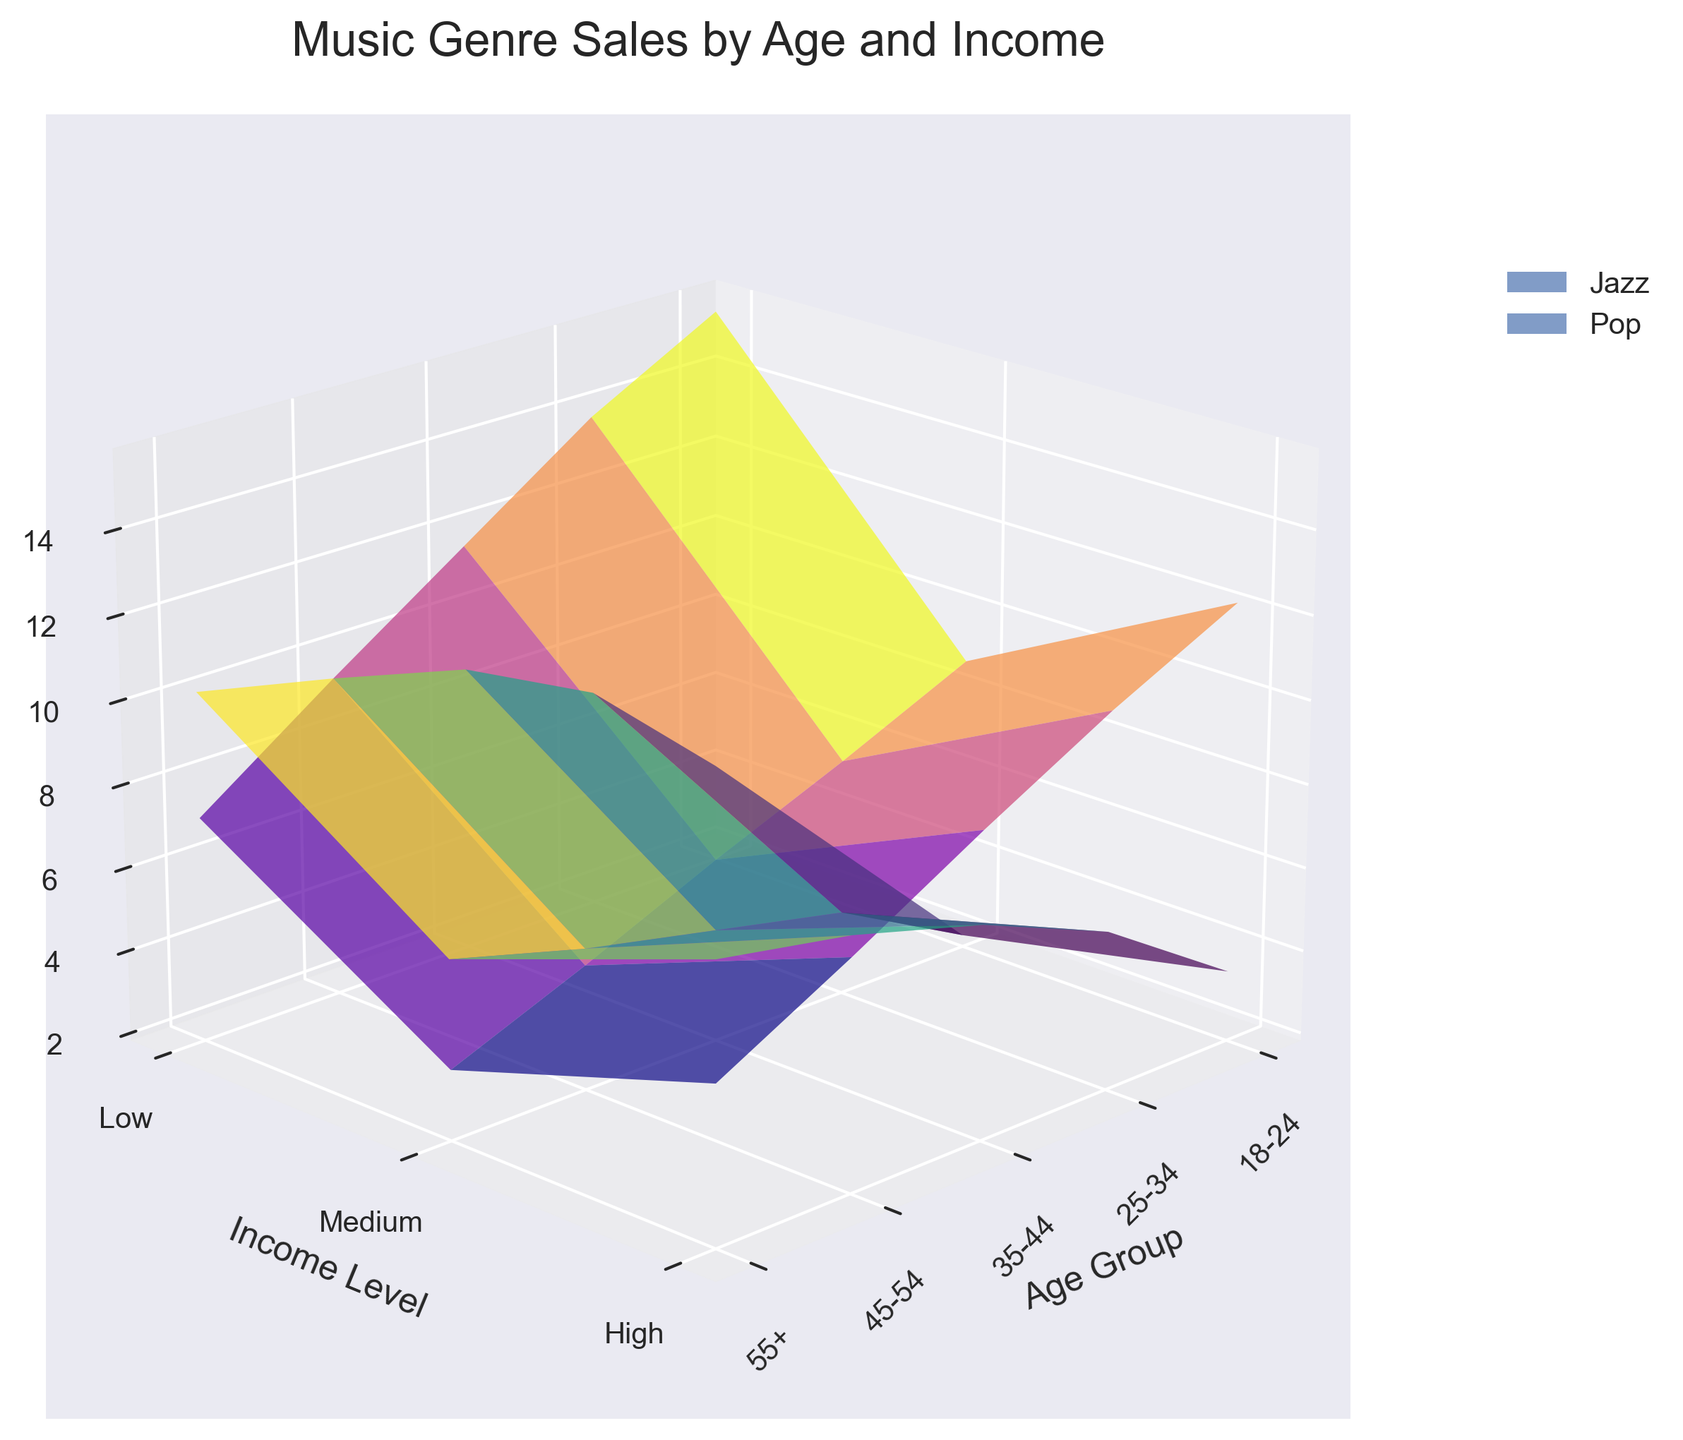What is the title of the 3D plot? The title is located at the top center of the plot, providing an overview of what the plot represents.
Answer: Music Genre Sales by Age and Income Which genre is represented by the `viridis` colormap? The `viridis` colormap is distinguishable by its green to yellow gradient, and it’s used for one of the surfaces in the plot.
Answer: Jazz How do the sales of Jazz compare between the low and high-income levels for the age group 35-44? By observing the height difference between the low and high income surfaces for the age group 35-44 in the Z-axis labeled as "Sales (millions)", we can see that the sales for the high-income group are significantly higher than those for the low-income group.
Answer: High-income sales are greater Which age group has the highest sales for Pop in the high-income level? By identifying the tallest surface point in the Pop genre for the high-income level, specifically looking at the rightmost category on the Y-axis (Income Level).
Answer: 18-24 Which income level shows the largest disparity in sales between Jazz and Pop for the age group 55+? To find the largest disparity, observe the difference in heights between the Jazz and Pop surfaces for the income levels within the age group 55+ and compare these differences for low, medium, and high-income levels.
Answer: Low income level How does the legend help in understanding the plot? The legend, located on the upper left or right outside the plot, helps differentiate between the surfaces representing Jazz and Pop by associating them with their respective colormaps.
Answer: It identifies genre colors What can be inferred about the trend of Pop sales as the age group increases within the medium income level? Tracking the surface heights associated with Pop across increasing age groups for the medium-income level reveals a downward trend in sales.
Answer: Pop sales decrease Which genre has a steeper sales increase from low to high-income levels for the age group 25-34? By comparing the steepness of the height increase from low to high income in the 25-34 age group, we see which surface rises more sharply along the Z-axis.
Answer: Jazz Is there any age group where Jazz sales surpass Pop sales in the medium-income level? Observing the surface heights for Jazz and Pop in medium income within each age group, check if any Jazz surface point is higher than the corresponding Pop surface point.
Answer: No For the age group 45-54, compare the sales difference between low and medium income levels for Jazz and Pop. Examine the Z-axis heights of the surfaces for Jazz and Pop in low and medium income. Calculate the sales difference for each genre and compare them.
Answer: Jazz has less disparity than Pop Which genre shows a more consistent increase in sales across all age groups for the high-income level? Looking at the height of the surfaces for each genre within the high-income level across all age groups, the one with a more stable, consistent rise indicates this trend.
Answer: Jazz 